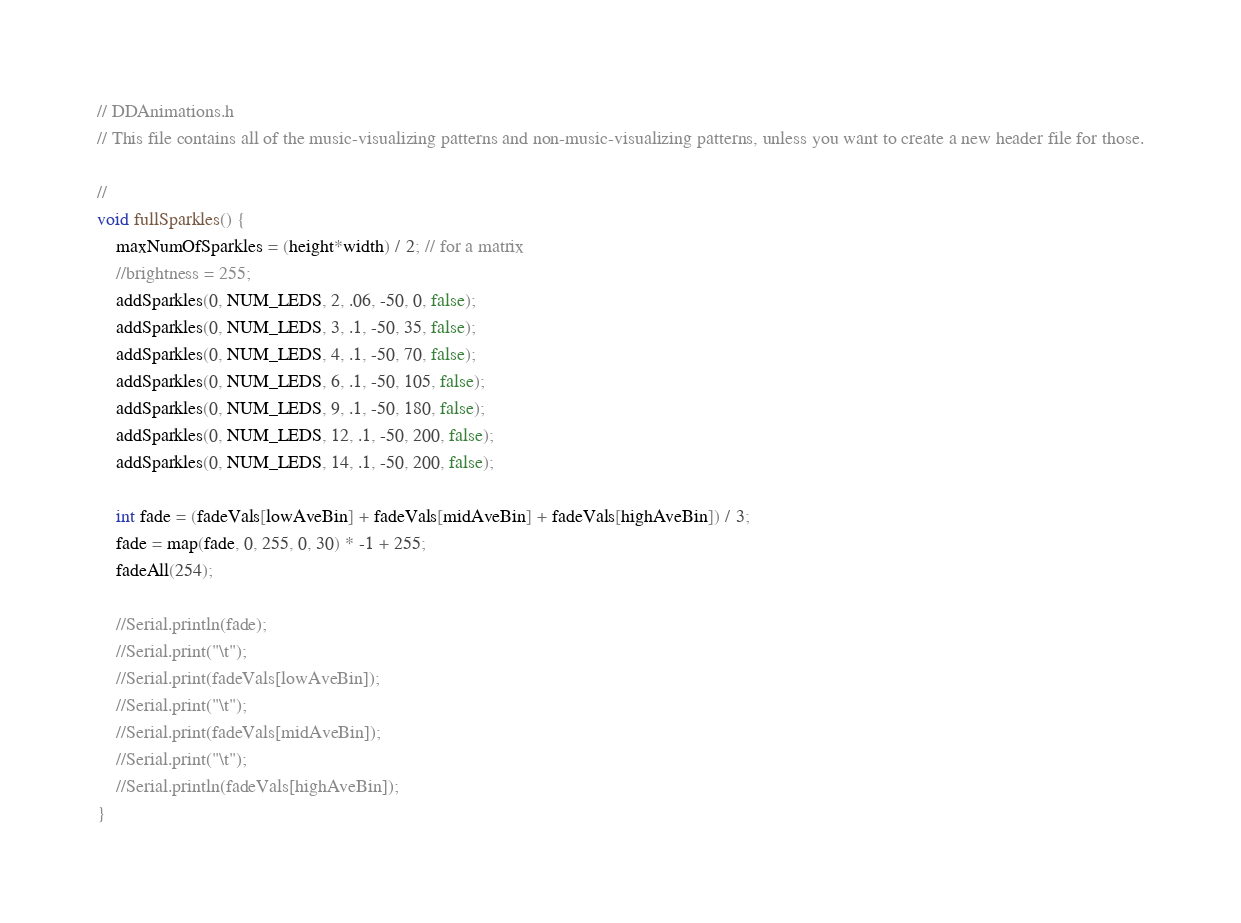<code> <loc_0><loc_0><loc_500><loc_500><_C_>// DDAnimations.h
// This file contains all of the music-visualizing patterns and non-music-visualizing patterns, unless you want to create a new header file for those.

// 
void fullSparkles() {
	maxNumOfSparkles = (height*width) / 2; // for a matrix
	//brightness = 255;
	addSparkles(0, NUM_LEDS, 2, .06, -50, 0, false);
	addSparkles(0, NUM_LEDS, 3, .1, -50, 35, false);
	addSparkles(0, NUM_LEDS, 4, .1, -50, 70, false);
	addSparkles(0, NUM_LEDS, 6, .1, -50, 105, false);
	addSparkles(0, NUM_LEDS, 9, .1, -50, 180, false);
	addSparkles(0, NUM_LEDS, 12, .1, -50, 200, false);
	addSparkles(0, NUM_LEDS, 14, .1, -50, 200, false);

	int fade = (fadeVals[lowAveBin] + fadeVals[midAveBin] + fadeVals[highAveBin]) / 3;
	fade = map(fade, 0, 255, 0, 30) * -1 + 255;
	fadeAll(254);

	//Serial.println(fade);
	//Serial.print("\t");
	//Serial.print(fadeVals[lowAveBin]);
	//Serial.print("\t");
	//Serial.print(fadeVals[midAveBin]);
	//Serial.print("\t");
	//Serial.println(fadeVals[highAveBin]);
}
</code> 